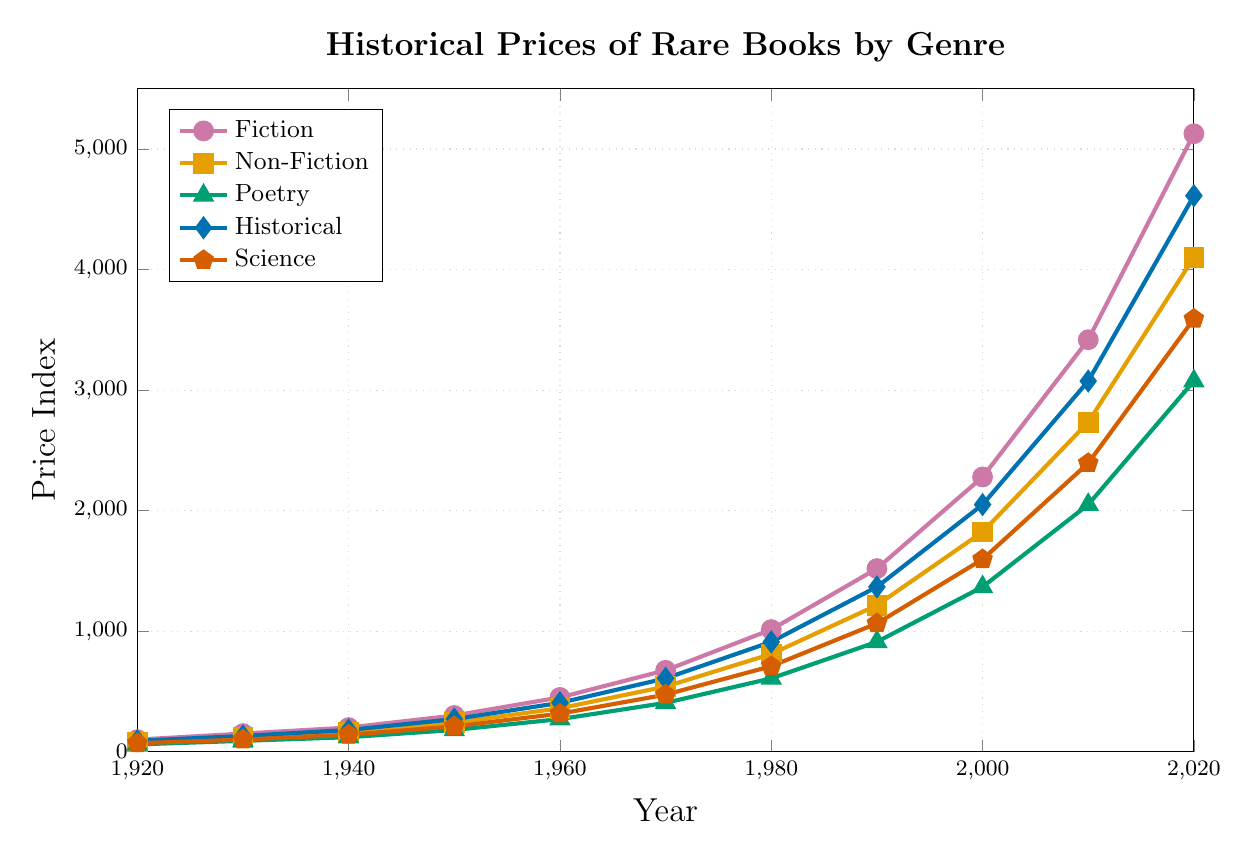What is the price difference between Fiction and Non-Fiction books in 2020? The price for Fiction books in 2020 is 5127, and the price for Non-Fiction books in 2020 is 4101. The difference is 5127 - 4101 = 1026.
Answer: 1026 Which genre had the highest price increase over the past century? By observing the price from 1920 to 2020 for all genres, Fiction increases from 100 to 5127, Non-Fiction from 80 to 4101, Poetry from 60 to 3075, Historical from 90 to 4613, and Science from 70 to 3591. The highest increase is in Fiction (5127 - 100 = 5027).
Answer: Fiction Around which decade did the prices of Fiction surpass the prices of Historical books? By examining the plot, Fiction prices surpass Historical prices between 1980 (Fiction 1013, Historical 911) and 1990 (Fiction 1519, Historical 1367).
Answer: 1980s What was the price of Poetry books in 1950, and how does it compare to the price in 1960? The price of Poetry books in 1950 was 180. In 1960, it was 270. The increase is 270 - 180 = 90.
Answer: 270, increased by 90 Which genre had the smallest price value in 1940? The smallest price in 1940 is for Poetry, which is 120.
Answer: Poetry How did the price of Science books change from 1920 to 1970? In 1920, the price for Science books was 70, and in 1970 it was 473. The change is 473 - 70 = 403.
Answer: Increased by 403 What is the average price of Non-Fiction books over the decades shown? Non-Fiction prices across decades are 80, 120, 160, 240, 360, 540, 810, 1215, 1823, 2734, and 4101. The sum is 12183, and the average is 12183 / 11 ≈ 1107.
Answer: 1107 Which genre's price surpassed the 1000 mark first and in which year? By examining the plot, Fiction surpassed the 1000 mark first in 1980 with a price of 1013.
Answer: Fiction, 1980 What is the total price of Historical and Science books in 2020? The price of Historical books in 2020 is 4613, and the price of Science books is 3591. The total is 4613 + 3591 = 8204.
Answer: 8204 